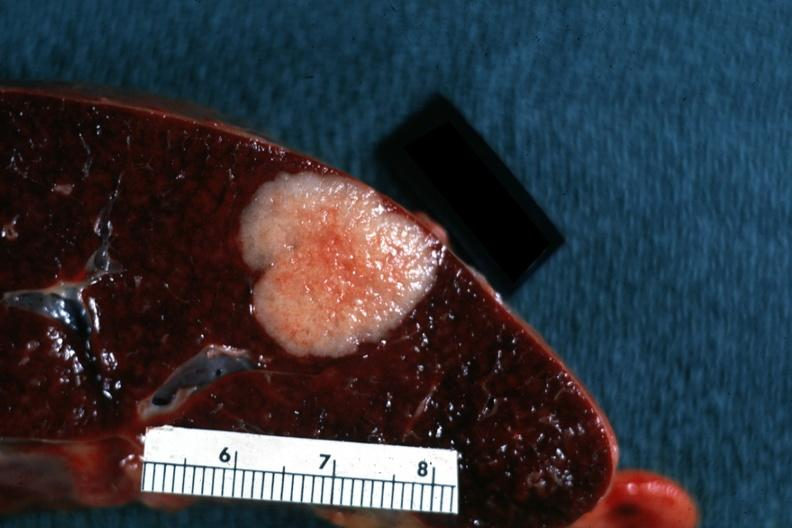what is present?
Answer the question using a single word or phrase. Hematologic 